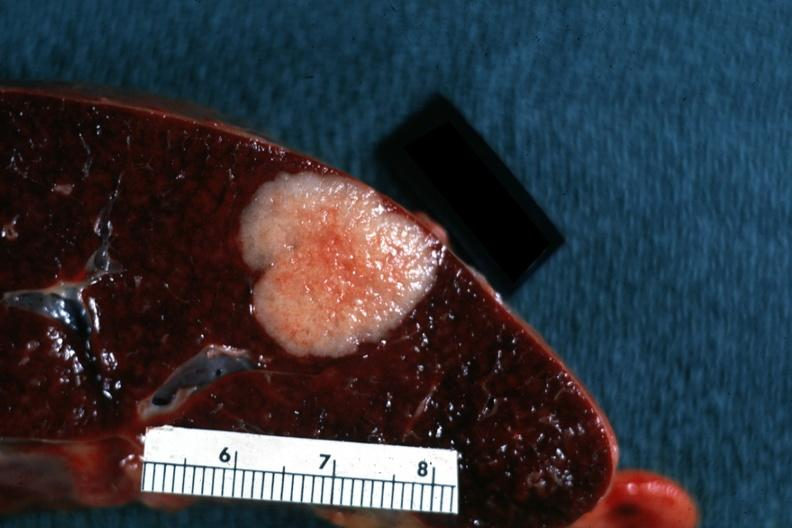what is present?
Answer the question using a single word or phrase. Hematologic 